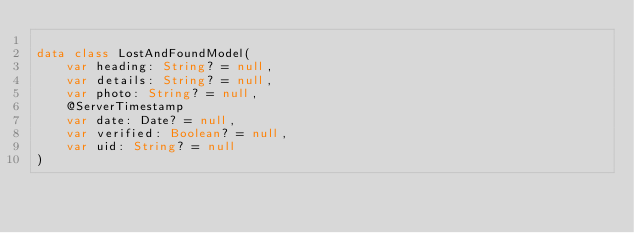Convert code to text. <code><loc_0><loc_0><loc_500><loc_500><_Kotlin_>
data class LostAndFoundModel(
    var heading: String? = null,
    var details: String? = null,
    var photo: String? = null,
    @ServerTimestamp
    var date: Date? = null,
    var verified: Boolean? = null,
    var uid: String? = null
)
</code> 